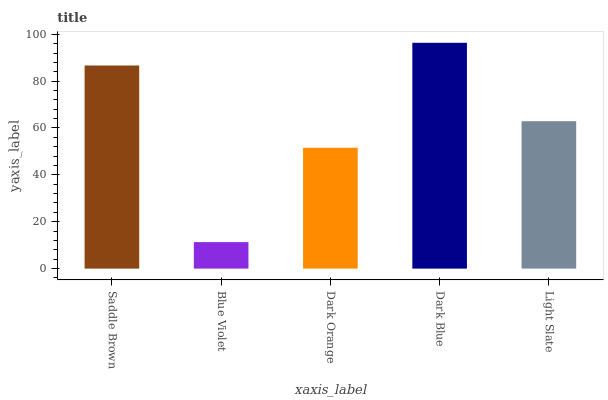Is Blue Violet the minimum?
Answer yes or no. Yes. Is Dark Blue the maximum?
Answer yes or no. Yes. Is Dark Orange the minimum?
Answer yes or no. No. Is Dark Orange the maximum?
Answer yes or no. No. Is Dark Orange greater than Blue Violet?
Answer yes or no. Yes. Is Blue Violet less than Dark Orange?
Answer yes or no. Yes. Is Blue Violet greater than Dark Orange?
Answer yes or no. No. Is Dark Orange less than Blue Violet?
Answer yes or no. No. Is Light Slate the high median?
Answer yes or no. Yes. Is Light Slate the low median?
Answer yes or no. Yes. Is Saddle Brown the high median?
Answer yes or no. No. Is Dark Blue the low median?
Answer yes or no. No. 